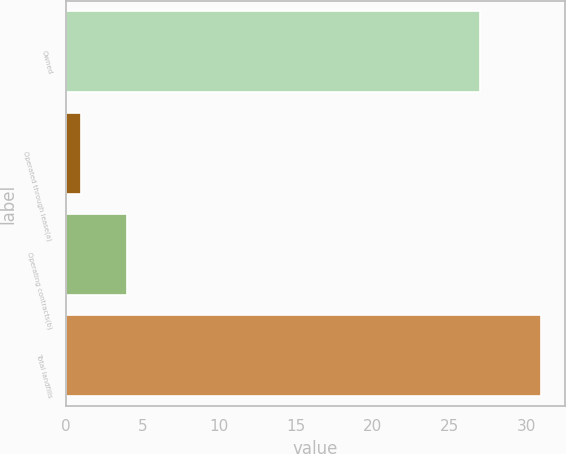Convert chart to OTSL. <chart><loc_0><loc_0><loc_500><loc_500><bar_chart><fcel>Owned<fcel>Operated through lease(a)<fcel>Operating contracts(b)<fcel>Total landfills<nl><fcel>27<fcel>1<fcel>4<fcel>31<nl></chart> 